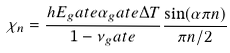Convert formula to latex. <formula><loc_0><loc_0><loc_500><loc_500>\chi _ { n } = \frac { h E _ { g } a t e \alpha _ { g } a t e \Delta T } { 1 - \nu _ { g } a t e } \frac { \sin ( \alpha \pi n ) } { \pi n / 2 }</formula> 